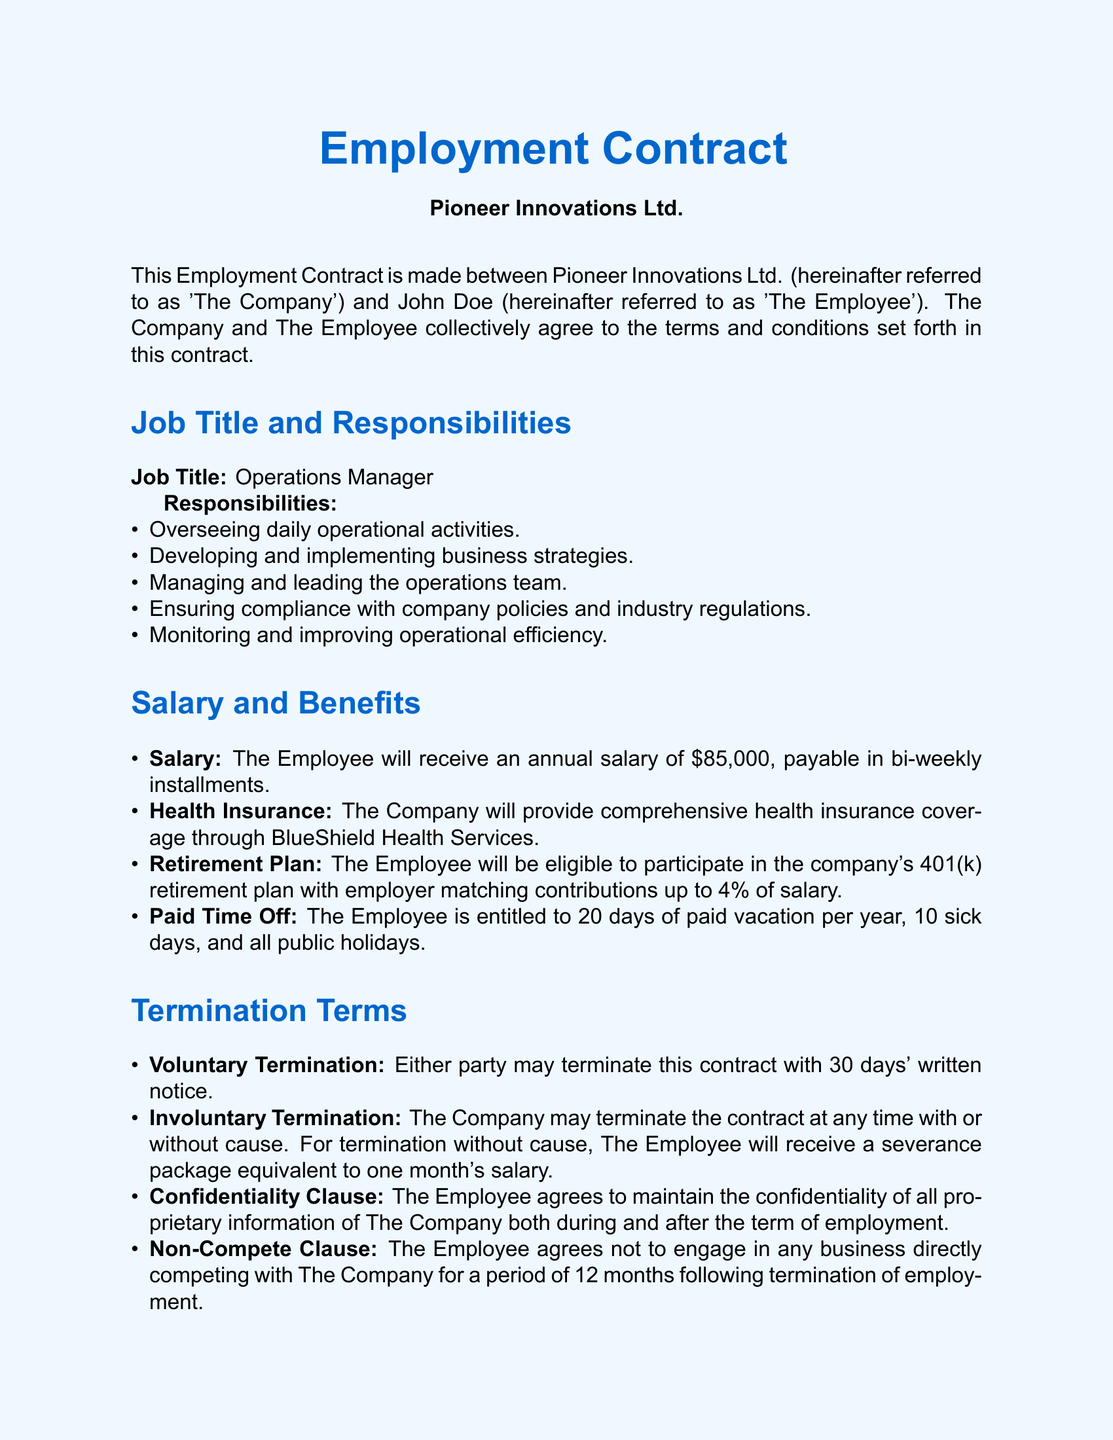what is the job title? The job title is specified in the Job Title and Responsibilities section of the document.
Answer: Operations Manager what is the annual salary? The annual salary is stated in the Salary and Benefits section of the document.
Answer: $85,000 how many paid vacation days does the employee get? The number of paid vacation days is mentioned in the Paid Time Off subsection of the document.
Answer: 20 days who is the CEO of the company? The name of the CEO is provided in the signature section of the document.
Answer: Jane Smith what is the notice period for voluntary termination? The notice period is described under the Termination Terms section of the document.
Answer: 30 days what happens if the company terminates the employee without cause? The condition regarding termination without cause is given in the Termination Terms section of the document.
Answer: one month's salary what is the duration of the non-compete clause? The duration of the non-compete clause is specified in the Termination Terms section.
Answer: 12 months which state's laws govern this contract? The governing laws are indicated at the end of the document.
Answer: California who is referred to as 'The Employee'? The document specifies the individual referred to as 'The Employee' in the introductory paragraph.
Answer: John Doe 